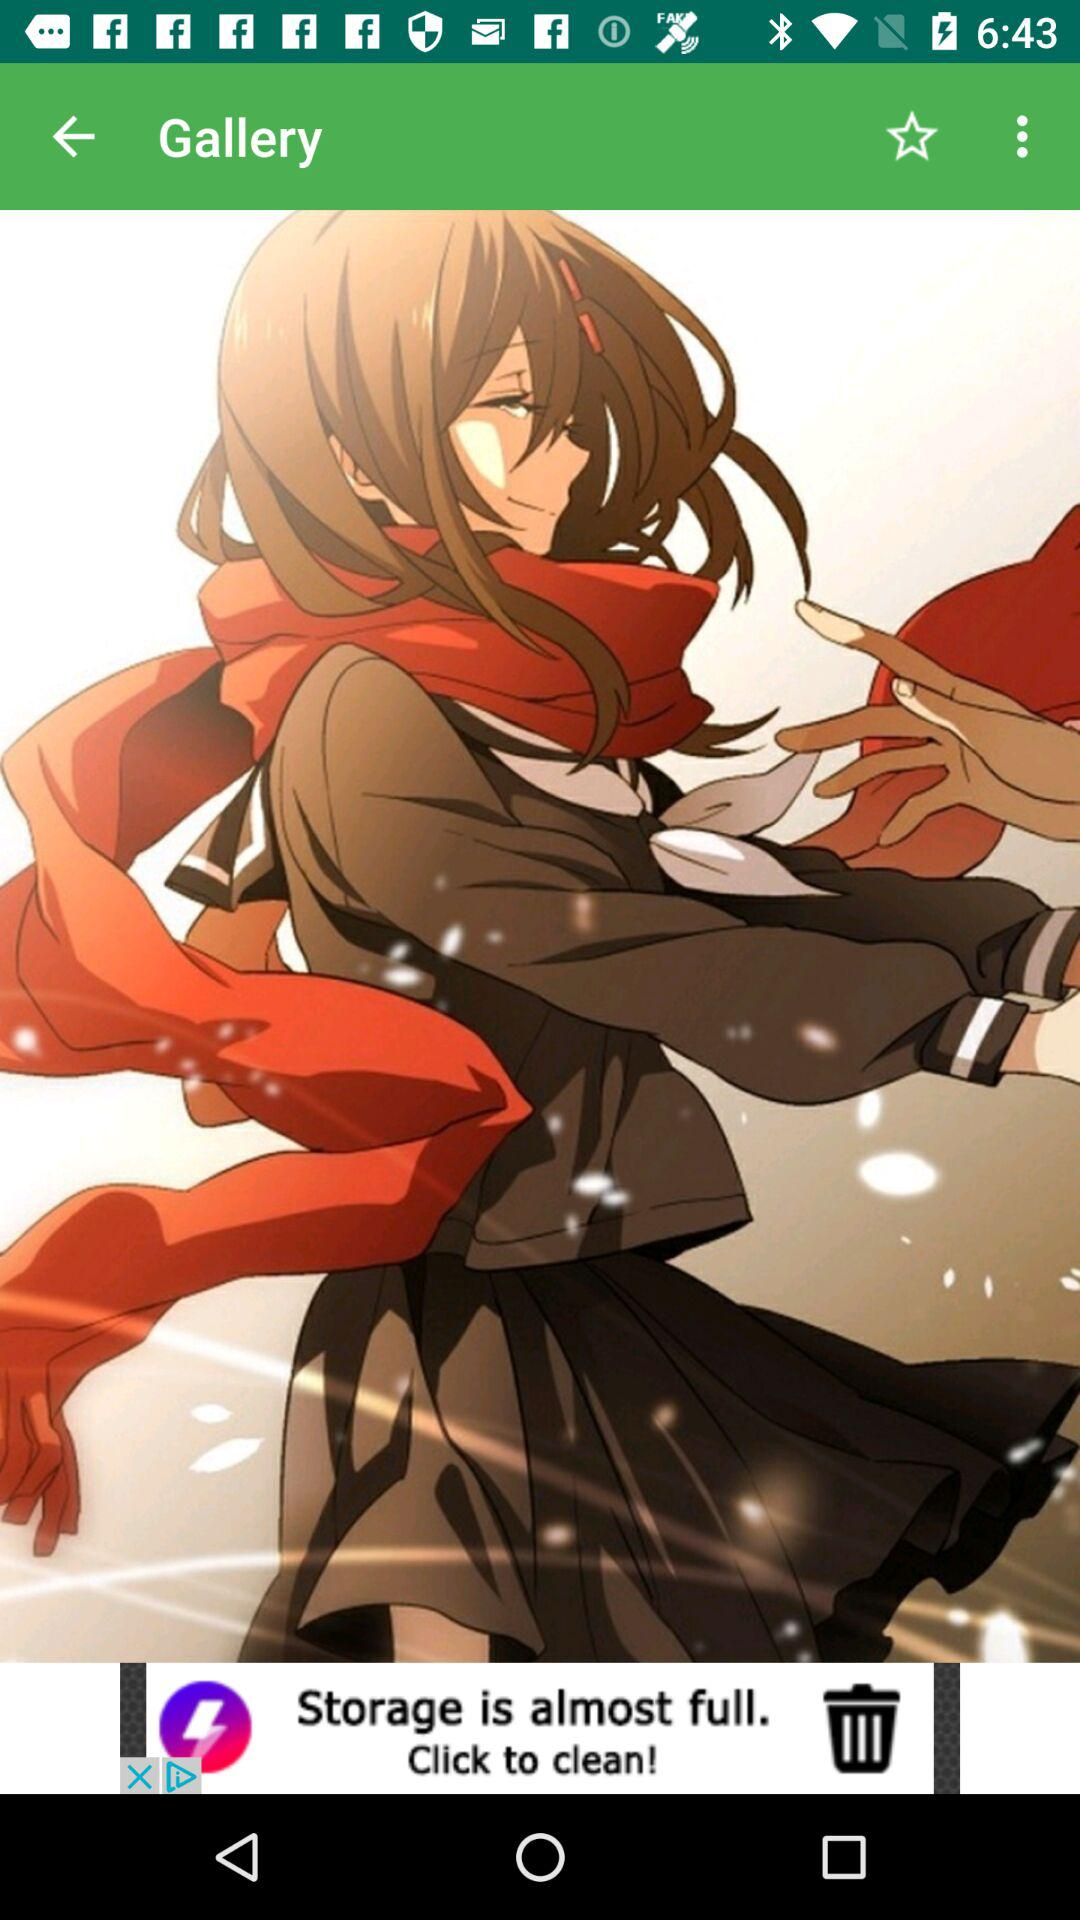What is the application name?
When the provided information is insufficient, respond with <no answer>. <no answer> 